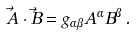Convert formula to latex. <formula><loc_0><loc_0><loc_500><loc_500>\vec { A } \cdot \vec { B } = g _ { \alpha \beta } A ^ { \alpha } B ^ { \beta } \, .</formula> 